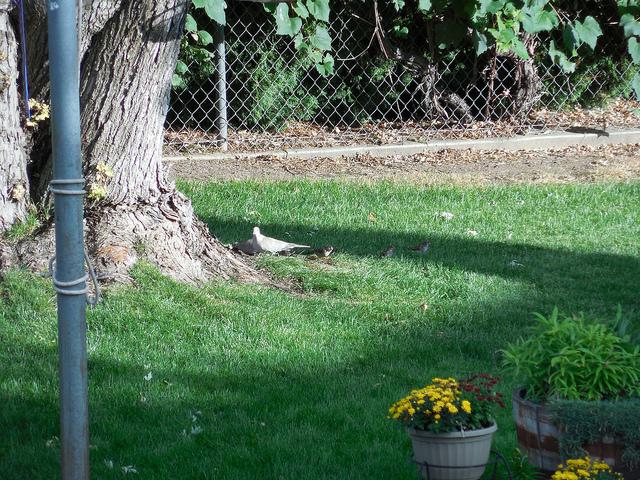What animal is sitting under the large tree?
Be succinct. Bird. What color is the container in the foreground?
Concise answer only. Green. What process do the green items shown use to convert sunlight into energy?
Short answer required. Photosynthesis. How many birds are in this photo?
Quick response, please. 1. Are those wood chips on the ground?
Write a very short answer. No. What color is the vase?
Concise answer only. White. What's holding back the vegetation in the background?
Answer briefly. Fence. 